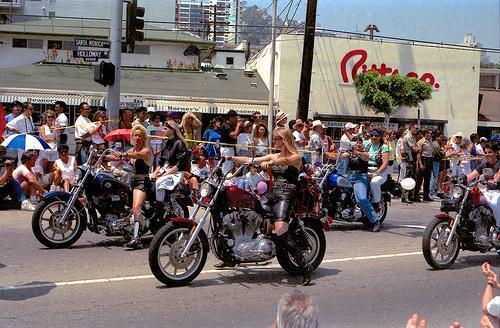How many blue motorcycles?
Give a very brief answer. 2. 